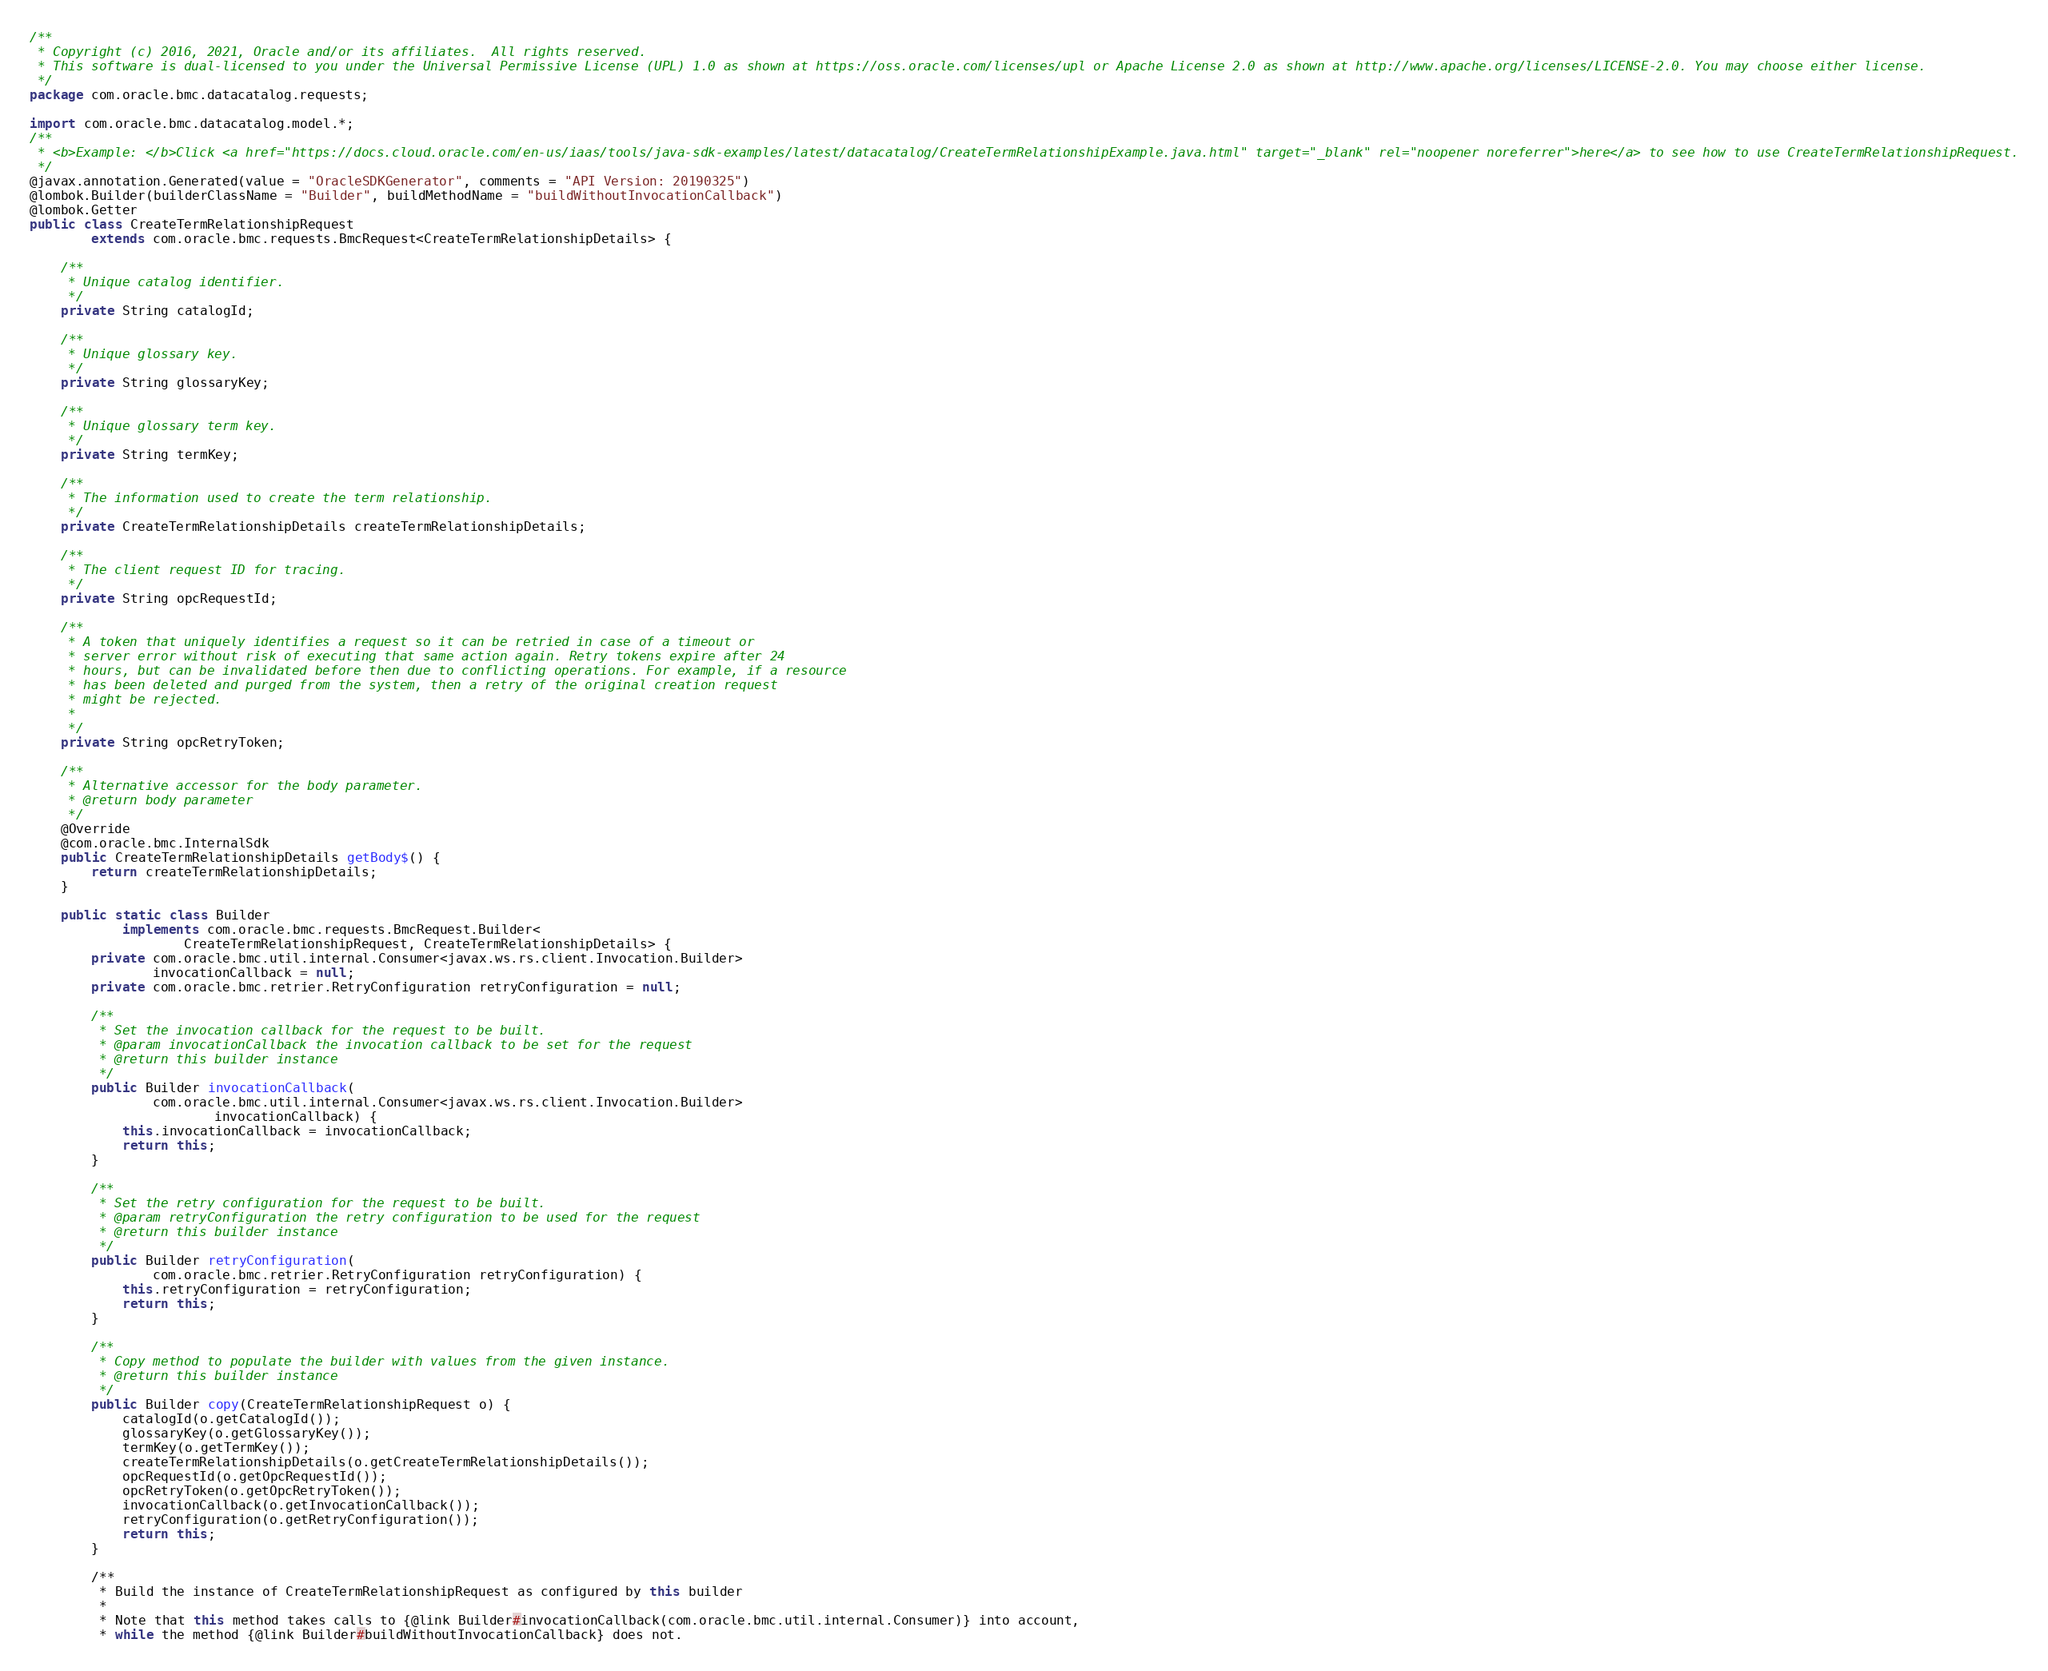<code> <loc_0><loc_0><loc_500><loc_500><_Java_>/**
 * Copyright (c) 2016, 2021, Oracle and/or its affiliates.  All rights reserved.
 * This software is dual-licensed to you under the Universal Permissive License (UPL) 1.0 as shown at https://oss.oracle.com/licenses/upl or Apache License 2.0 as shown at http://www.apache.org/licenses/LICENSE-2.0. You may choose either license.
 */
package com.oracle.bmc.datacatalog.requests;

import com.oracle.bmc.datacatalog.model.*;
/**
 * <b>Example: </b>Click <a href="https://docs.cloud.oracle.com/en-us/iaas/tools/java-sdk-examples/latest/datacatalog/CreateTermRelationshipExample.java.html" target="_blank" rel="noopener noreferrer">here</a> to see how to use CreateTermRelationshipRequest.
 */
@javax.annotation.Generated(value = "OracleSDKGenerator", comments = "API Version: 20190325")
@lombok.Builder(builderClassName = "Builder", buildMethodName = "buildWithoutInvocationCallback")
@lombok.Getter
public class CreateTermRelationshipRequest
        extends com.oracle.bmc.requests.BmcRequest<CreateTermRelationshipDetails> {

    /**
     * Unique catalog identifier.
     */
    private String catalogId;

    /**
     * Unique glossary key.
     */
    private String glossaryKey;

    /**
     * Unique glossary term key.
     */
    private String termKey;

    /**
     * The information used to create the term relationship.
     */
    private CreateTermRelationshipDetails createTermRelationshipDetails;

    /**
     * The client request ID for tracing.
     */
    private String opcRequestId;

    /**
     * A token that uniquely identifies a request so it can be retried in case of a timeout or
     * server error without risk of executing that same action again. Retry tokens expire after 24
     * hours, but can be invalidated before then due to conflicting operations. For example, if a resource
     * has been deleted and purged from the system, then a retry of the original creation request
     * might be rejected.
     *
     */
    private String opcRetryToken;

    /**
     * Alternative accessor for the body parameter.
     * @return body parameter
     */
    @Override
    @com.oracle.bmc.InternalSdk
    public CreateTermRelationshipDetails getBody$() {
        return createTermRelationshipDetails;
    }

    public static class Builder
            implements com.oracle.bmc.requests.BmcRequest.Builder<
                    CreateTermRelationshipRequest, CreateTermRelationshipDetails> {
        private com.oracle.bmc.util.internal.Consumer<javax.ws.rs.client.Invocation.Builder>
                invocationCallback = null;
        private com.oracle.bmc.retrier.RetryConfiguration retryConfiguration = null;

        /**
         * Set the invocation callback for the request to be built.
         * @param invocationCallback the invocation callback to be set for the request
         * @return this builder instance
         */
        public Builder invocationCallback(
                com.oracle.bmc.util.internal.Consumer<javax.ws.rs.client.Invocation.Builder>
                        invocationCallback) {
            this.invocationCallback = invocationCallback;
            return this;
        }

        /**
         * Set the retry configuration for the request to be built.
         * @param retryConfiguration the retry configuration to be used for the request
         * @return this builder instance
         */
        public Builder retryConfiguration(
                com.oracle.bmc.retrier.RetryConfiguration retryConfiguration) {
            this.retryConfiguration = retryConfiguration;
            return this;
        }

        /**
         * Copy method to populate the builder with values from the given instance.
         * @return this builder instance
         */
        public Builder copy(CreateTermRelationshipRequest o) {
            catalogId(o.getCatalogId());
            glossaryKey(o.getGlossaryKey());
            termKey(o.getTermKey());
            createTermRelationshipDetails(o.getCreateTermRelationshipDetails());
            opcRequestId(o.getOpcRequestId());
            opcRetryToken(o.getOpcRetryToken());
            invocationCallback(o.getInvocationCallback());
            retryConfiguration(o.getRetryConfiguration());
            return this;
        }

        /**
         * Build the instance of CreateTermRelationshipRequest as configured by this builder
         *
         * Note that this method takes calls to {@link Builder#invocationCallback(com.oracle.bmc.util.internal.Consumer)} into account,
         * while the method {@link Builder#buildWithoutInvocationCallback} does not.</code> 